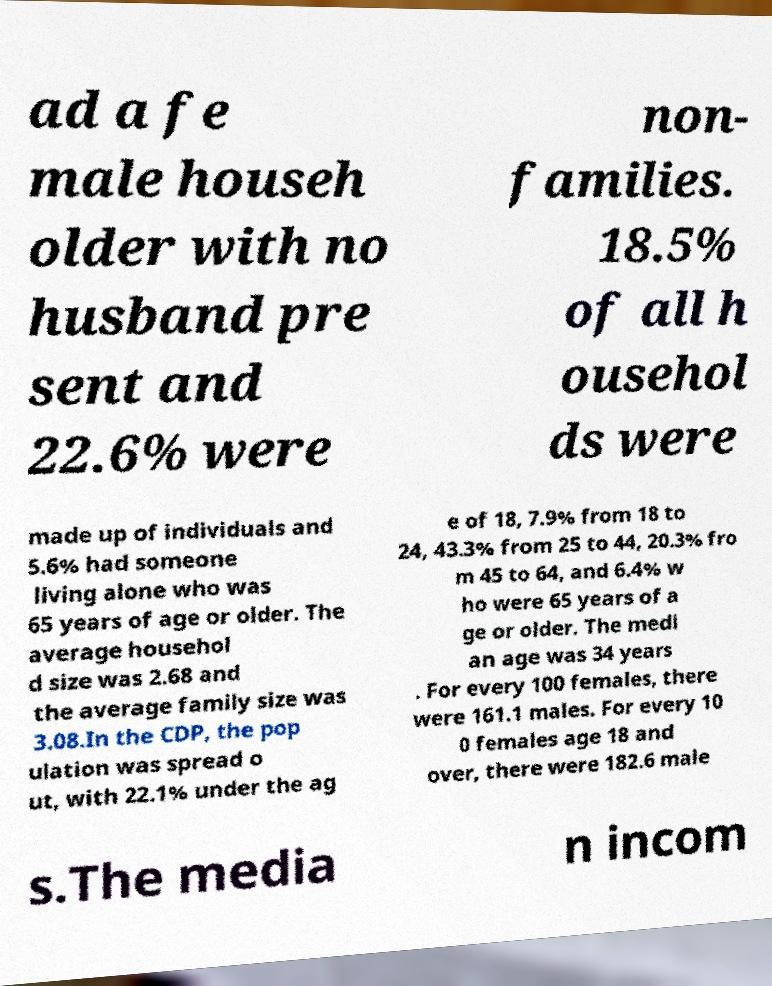Could you extract and type out the text from this image? ad a fe male househ older with no husband pre sent and 22.6% were non- families. 18.5% of all h ousehol ds were made up of individuals and 5.6% had someone living alone who was 65 years of age or older. The average househol d size was 2.68 and the average family size was 3.08.In the CDP, the pop ulation was spread o ut, with 22.1% under the ag e of 18, 7.9% from 18 to 24, 43.3% from 25 to 44, 20.3% fro m 45 to 64, and 6.4% w ho were 65 years of a ge or older. The medi an age was 34 years . For every 100 females, there were 161.1 males. For every 10 0 females age 18 and over, there were 182.6 male s.The media n incom 